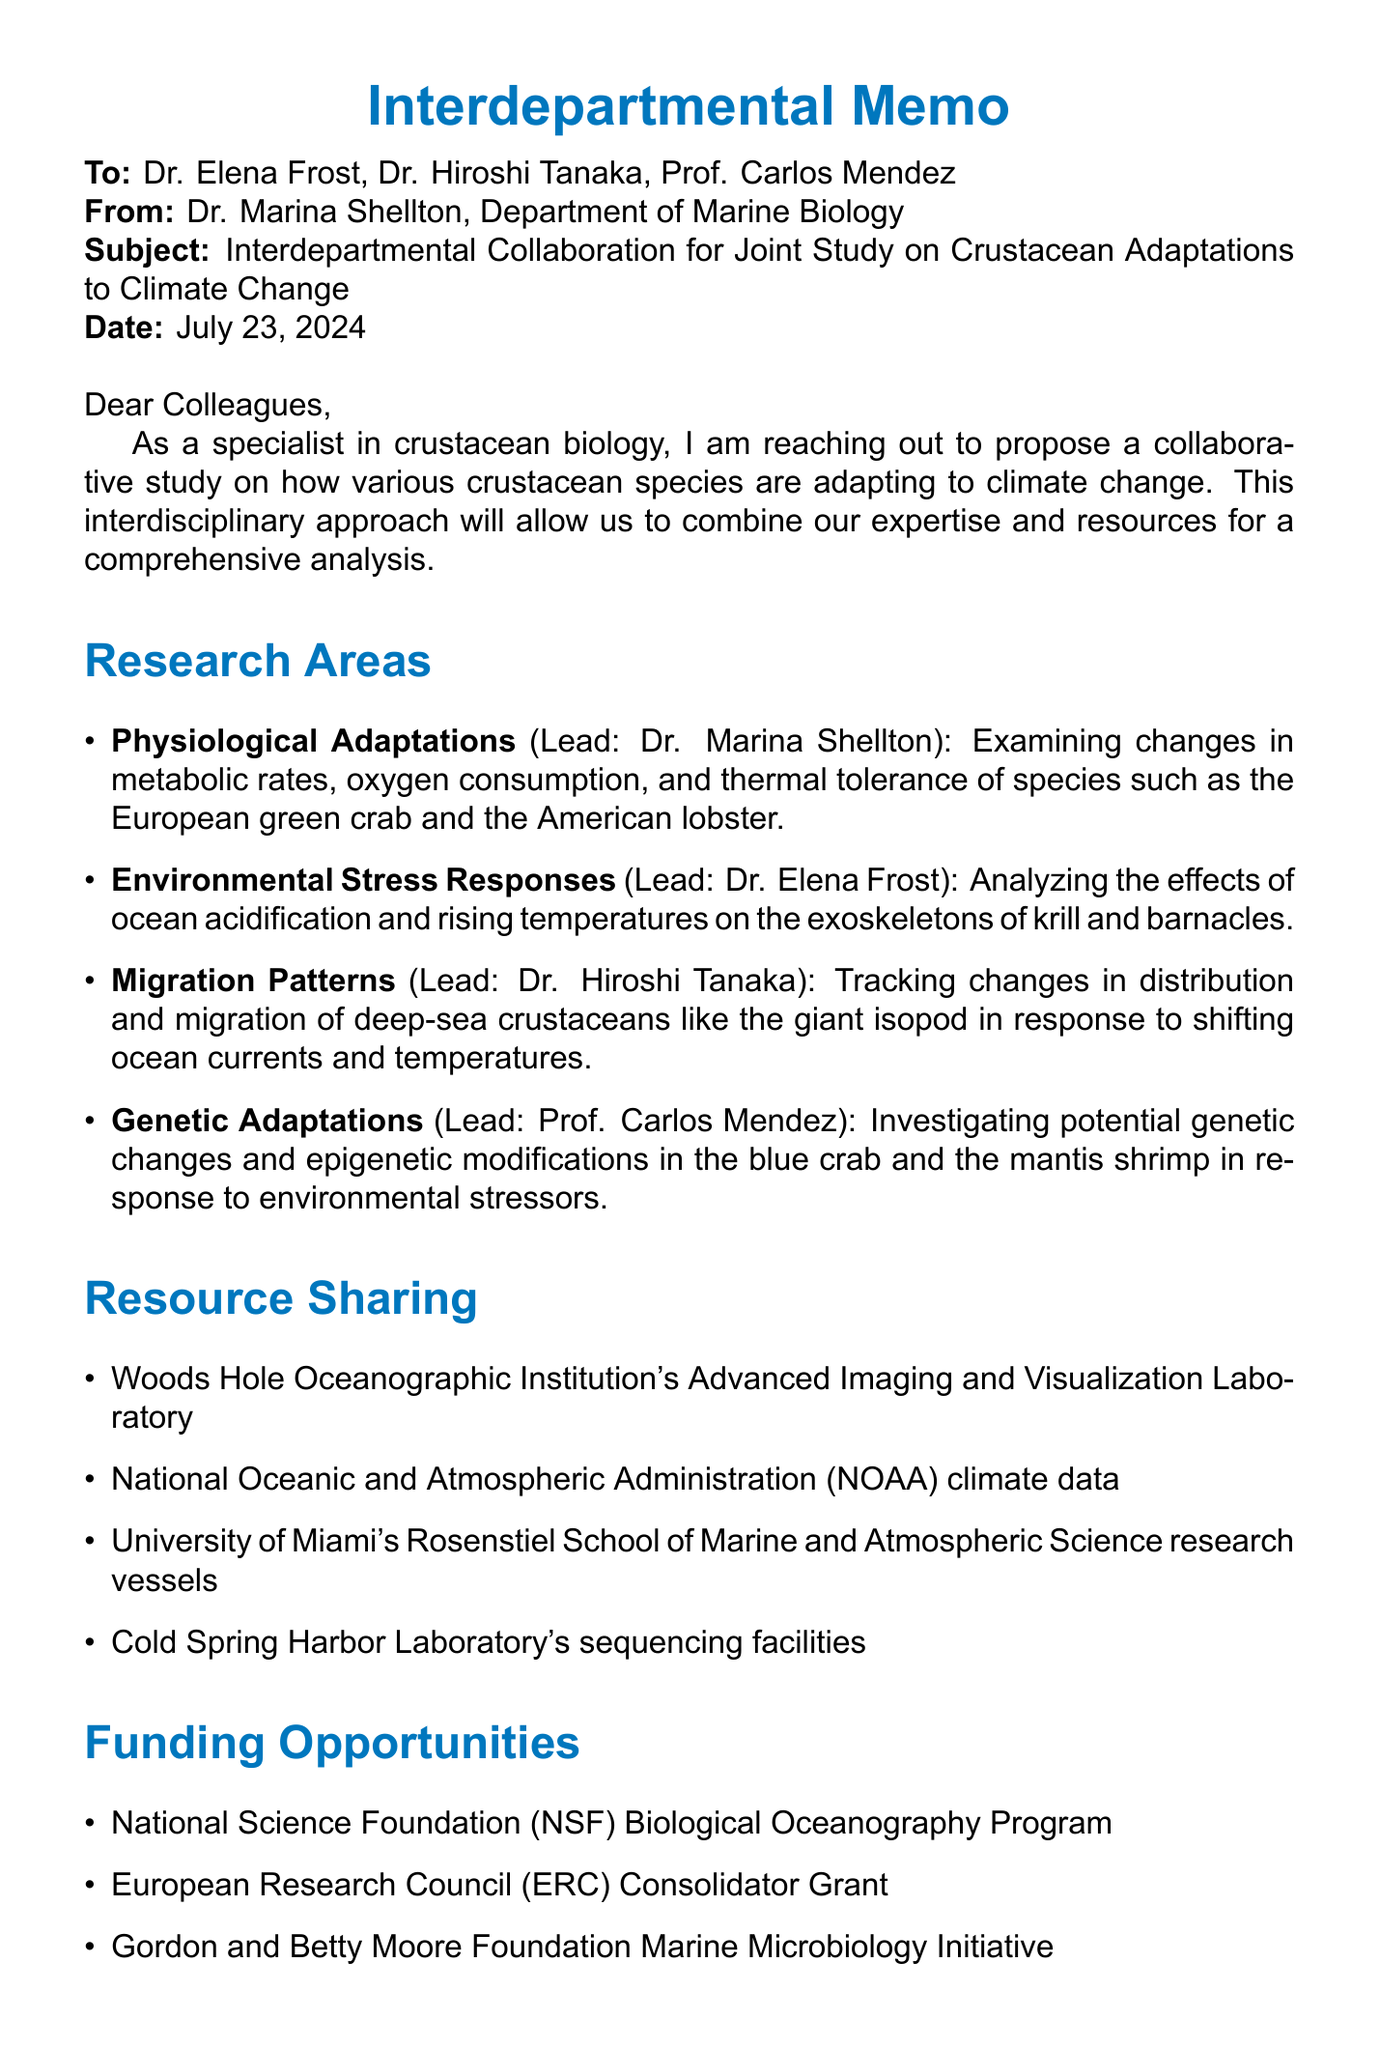What is the subject of the memo? The subject is explicitly stated in the document and focuses on collaboration for a specific study.
Answer: Interdepartmental Collaboration for Joint Study on Crustacean Adaptations to Climate Change Who sent the memo? The sender of the memo is indicated at the beginning of the document, providing information about the author.
Answer: Dr. Marina Shellton Which crustacean species are involved in the physiological adaptations research area? The species mentioned in the research area for physiological adaptations are specified.
Answer: European green crab, American lobster What resource is shared for high-resolution imaging? The specific resource allocated for imaging purposes is detailed under resource sharing.
Answer: Woods Hole Oceanographic Institution's Advanced Imaging and Visualization Laboratory When is the first progress report due? The proposed timeline section outlines the deadlines for various reports, including the first progress report.
Answer: March 1, 2024 Which department leads the research on environmental stress responses? The document specifies which researcher leads each research area and their affiliated department.
Answer: Department of Environmental Sciences What are the funding opportunities listed in the memo? The memo includes a list of potential funding sources, detailing opportunities for the collaborative project.
Answer: National Science Foundation (NSF) Biological Oceanography Program, European Research Council (ERC) Consolidator Grant, Gordon and Betty Moore Foundation Marine Microbiology Initiative What is the proposed start date for the project? The project start date is explicitly stated in the proposed timeline section.
Answer: September 1, 2023 What is the next step regarding an interdepartmental meeting? The next steps include specific actions to be taken after the proposal, including scheduling meetings.
Answer: Schedule an interdepartmental meeting to discuss the proposal 